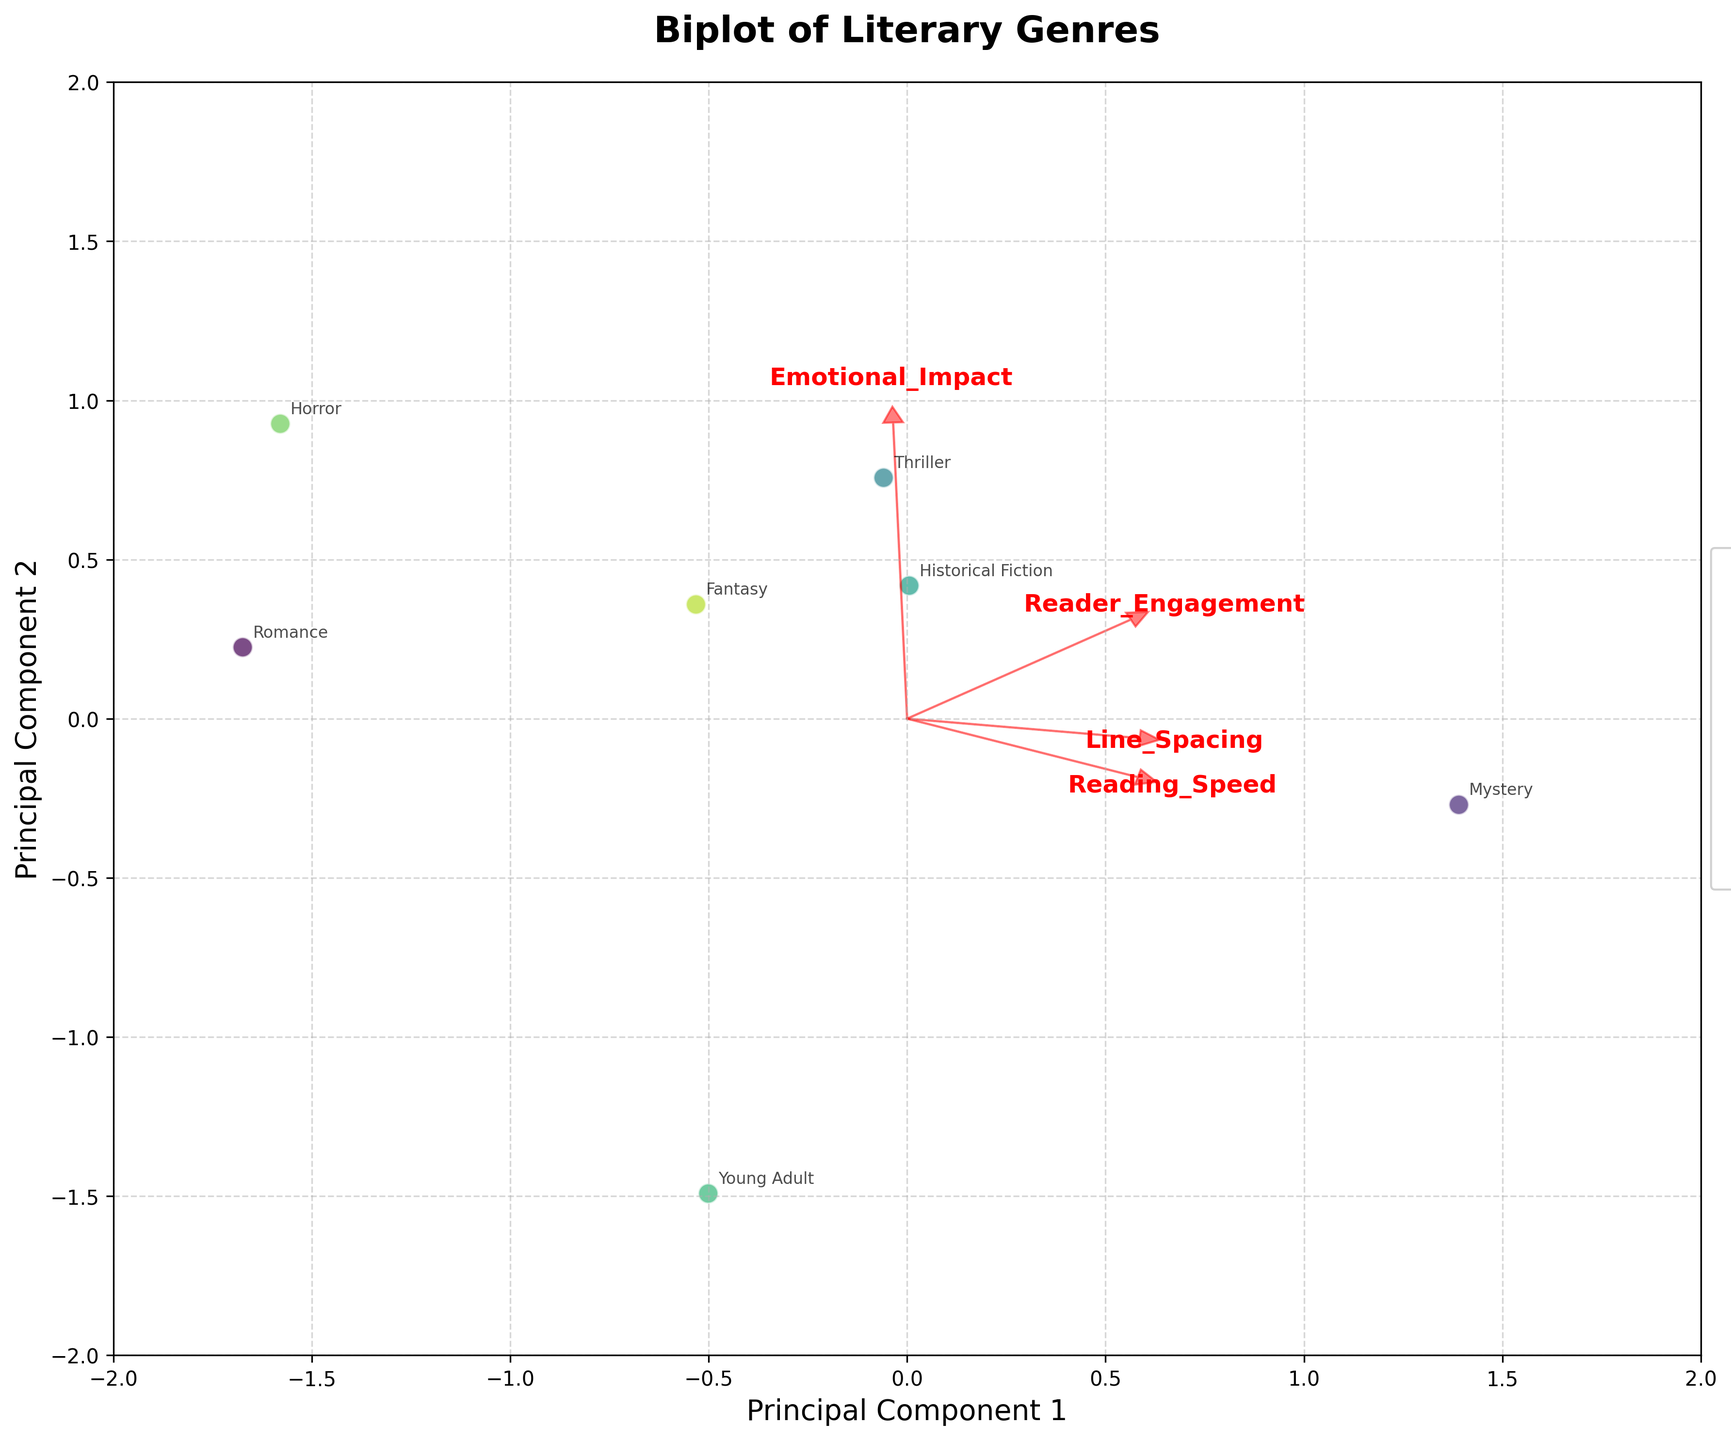What does the title of the plot indicate? The title is located at the top of the plot and gives a summary of the content. Here, the title "Biplot of Literary Genres" suggests that the plot represents genres of literature in a biplot format.
Answer: Biplot of Literary Genres Which axis represents the first principal component? The x-axis label "Principal Component 1" indicates that this axis represents the first principal component.
Answer: x-axis How many genres are represented in the plot? There is a legend on the right side of the plot that lists all the genres represented by the data points. By counting the items in the legend, we find there are 10 genres in total.
Answer: 10 What genre has the highest reader engagement? Checking the annotations on the plot, "Literary Fiction" is the genre listed at the position with the highest value on the 'Reader Engagement' feature vector.
Answer: Literary Fiction Which feature appears most correlated with Principal Component 1? The length and direction of the arrows indicate correlations. "Reader Engagement" has an arrow that points furthest in the direction of Principal Component 1, suggesting it's most correlated.
Answer: Reader Engagement How does line spacing vary with principal components? Line spacing feature vector can be visualized by its arrow direction and length. It seems to align more with Principal Component 2 rather than Principal Component 1. This suggests variation in line spacing is related to Principal Component 2.
Answer: Principal Component 2 What does the spacing between different genre points indicate? The distances between different genre points in the biplot suggest the dissimilarity in their attributes according to PCA. For example, genres closer together are more similar regarding the analyzed features, while those farther apart are more different.
Answer: Dissimilarity Which genres are the most different in terms of the analyzed features? By examining the plot, "Science Fiction" and "Non-fiction" are located the farthest apart, indicating they are the most different in terms of line spacing, reader engagement, emotional impact, and reading speed.
Answer: Science Fiction and Non-fiction Which feature vector is almost orthogonal to 'Emotional Impact'? In the plot, the feature vector for "Reading Speed" appears almost orthogonal (90 degrees) to "Emotional Impact," suggesting little to no correlation between these two features.
Answer: Reading Speed What might a longer arrow in the biplot represent for a feature? Longer arrows indicate stronger influence or higher variance contributed by that feature to the principal components.
Answer: Stronger influence 